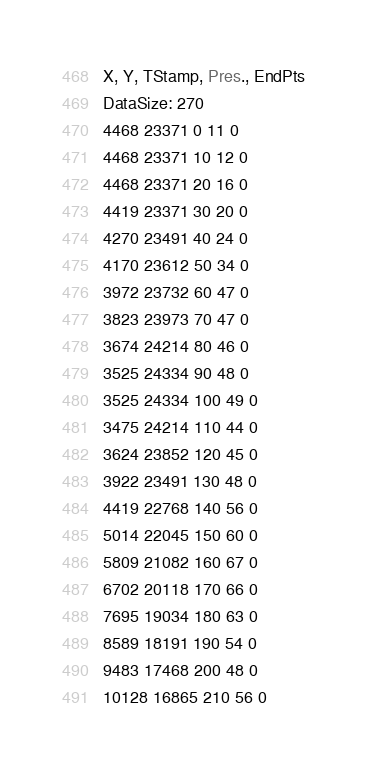Convert code to text. <code><loc_0><loc_0><loc_500><loc_500><_SML_>X, Y, TStamp, Pres., EndPts
DataSize: 270
4468 23371 0 11 0
4468 23371 10 12 0
4468 23371 20 16 0
4419 23371 30 20 0
4270 23491 40 24 0
4170 23612 50 34 0
3972 23732 60 47 0
3823 23973 70 47 0
3674 24214 80 46 0
3525 24334 90 48 0
3525 24334 100 49 0
3475 24214 110 44 0
3624 23852 120 45 0
3922 23491 130 48 0
4419 22768 140 56 0
5014 22045 150 60 0
5809 21082 160 67 0
6702 20118 170 66 0
7695 19034 180 63 0
8589 18191 190 54 0
9483 17468 200 48 0
10128 16865 210 56 0</code> 